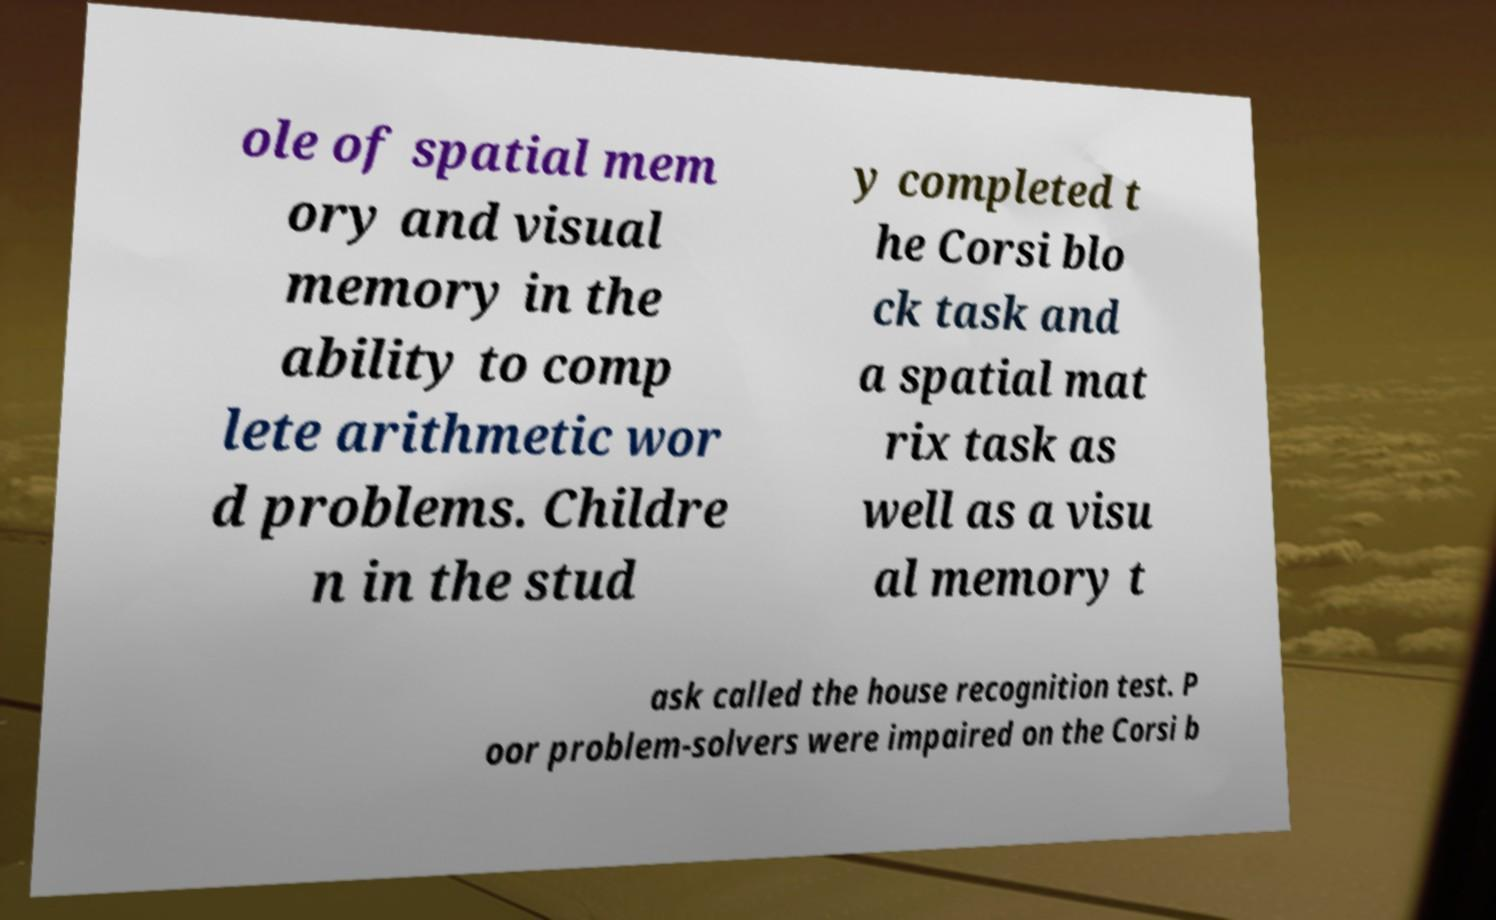Could you assist in decoding the text presented in this image and type it out clearly? ole of spatial mem ory and visual memory in the ability to comp lete arithmetic wor d problems. Childre n in the stud y completed t he Corsi blo ck task and a spatial mat rix task as well as a visu al memory t ask called the house recognition test. P oor problem-solvers were impaired on the Corsi b 